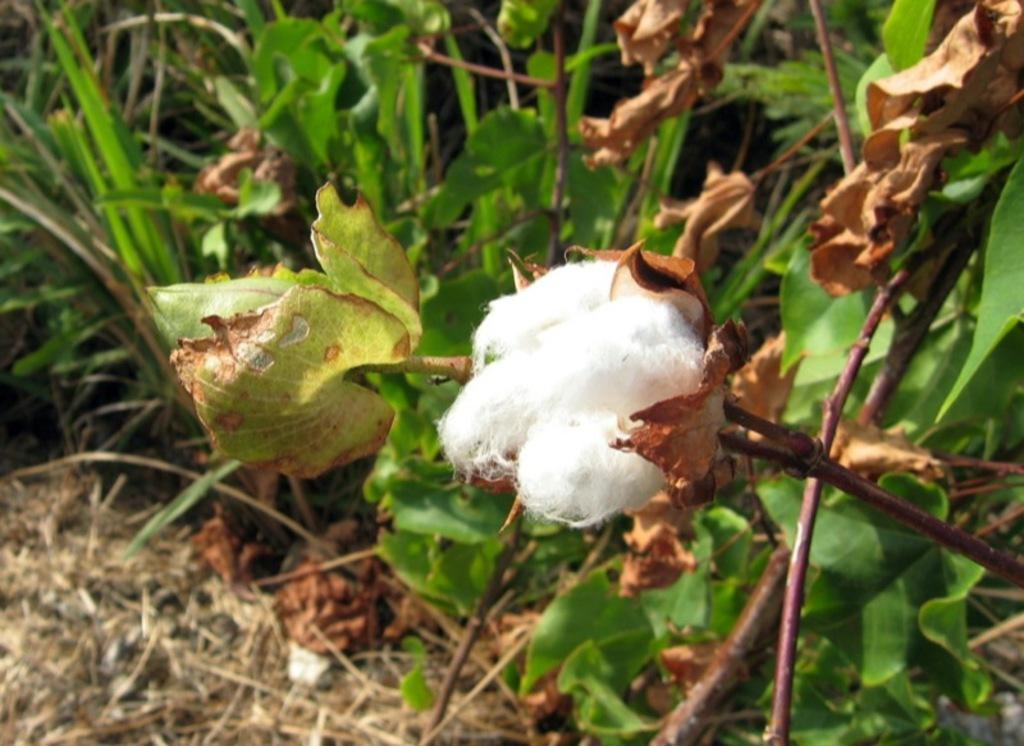What type of plant is the main subject of the image? There is a cotton plant in the image. What type of vegetation is present at the bottom of the image? Grass is present at the bottom of the image. What part of the cotton plant is visible in the image? Leaves are visible in the image. Where is the cotton located in the image? The cotton is located in the center of the image. What type of railway can be seen in the image? There is no railway present in the image; it features a cotton plant, grass, and leaves. How many twigs are visible in the image? There is no mention of twigs in the image; it only features a cotton plant, grass, and leaves. 